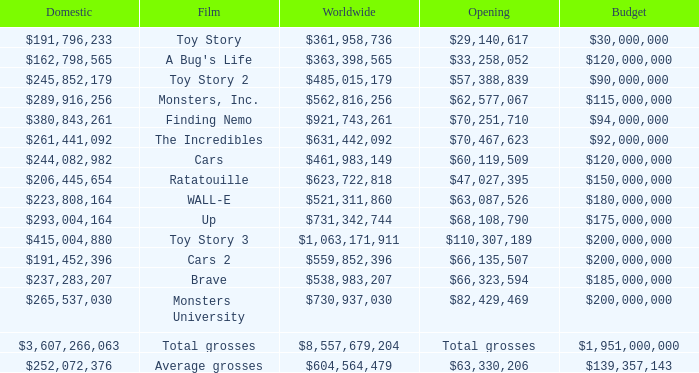WHAT IS THE WORLDWIDE BOX OFFICE FOR BRAVE? $538,983,207. 